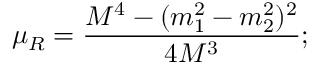<formula> <loc_0><loc_0><loc_500><loc_500>\mu _ { R } = \frac { M ^ { 4 } - ( m _ { 1 } ^ { 2 } - m _ { 2 } ^ { 2 } ) ^ { 2 } } { 4 M ^ { 3 } } ;</formula> 